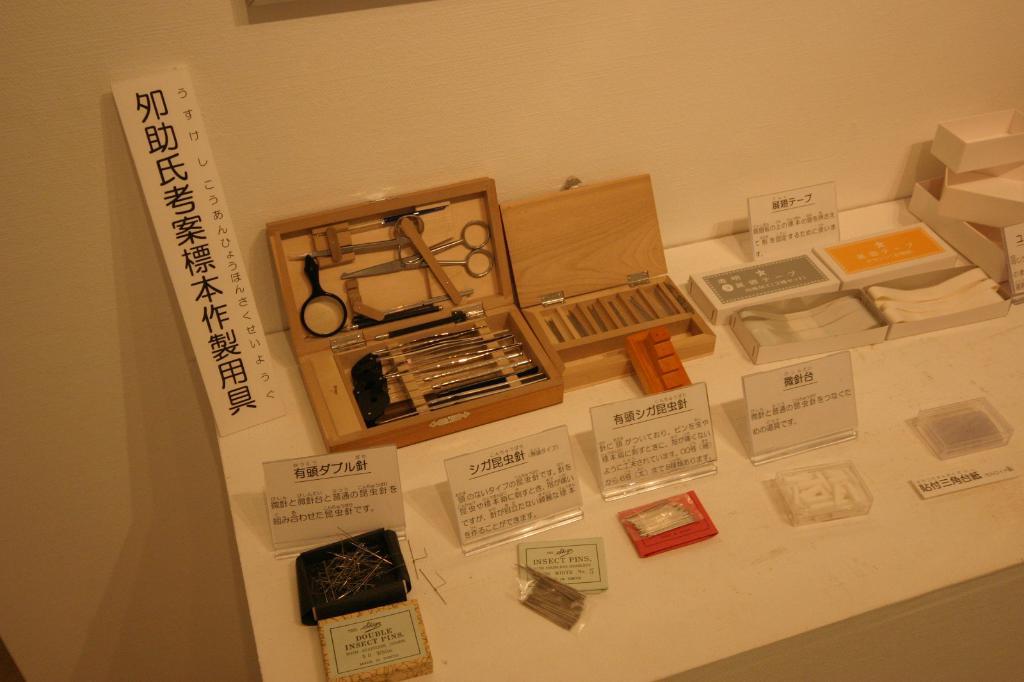If is the chinese?
Make the answer very short. Not a question. 